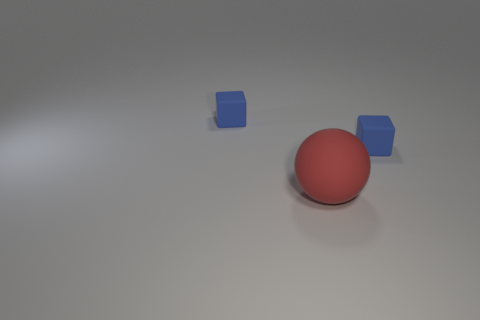Add 2 blocks. How many objects exist? 5 Subtract all blocks. How many objects are left? 1 Add 1 small blue cubes. How many small blue cubes are left? 3 Add 2 red balls. How many red balls exist? 3 Subtract 2 blue blocks. How many objects are left? 1 Subtract all small matte blocks. Subtract all red matte objects. How many objects are left? 0 